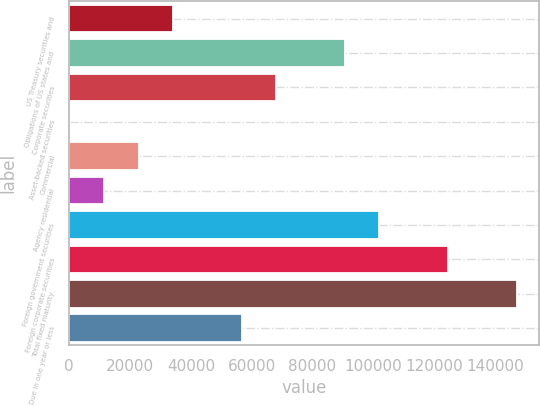Convert chart to OTSL. <chart><loc_0><loc_0><loc_500><loc_500><bar_chart><fcel>US Treasury securities and<fcel>Obligations of US states and<fcel>Corporate securities<fcel>Asset-backed securities<fcel>Commercial<fcel>Agency residential<fcel>Foreign government securities<fcel>Foreign corporate securities<fcel>Total fixed maturity<fcel>Due in one year or less<nl><fcel>34139.6<fcel>90680.6<fcel>68064.2<fcel>215<fcel>22831.4<fcel>11523.2<fcel>101989<fcel>124605<fcel>147222<fcel>56756<nl></chart> 